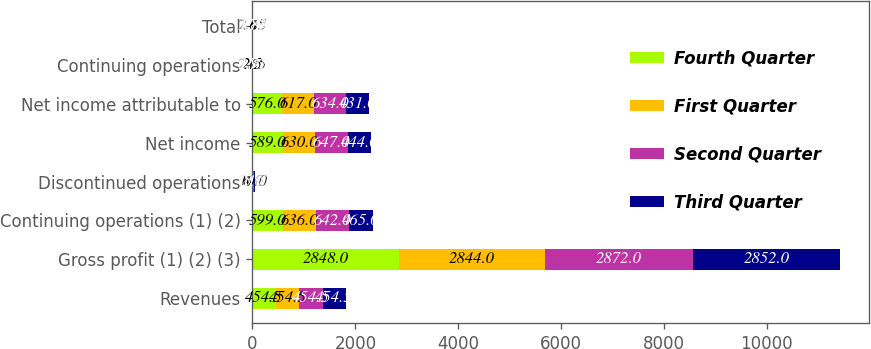Convert chart. <chart><loc_0><loc_0><loc_500><loc_500><stacked_bar_chart><ecel><fcel>Revenues<fcel>Gross profit (1) (2) (3)<fcel>Continuing operations (1) (2)<fcel>Discontinued operations<fcel>Net income<fcel>Net income attributable to<fcel>Continuing operations<fcel>Total<nl><fcel>Fourth Quarter<fcel>454.5<fcel>2848<fcel>599<fcel>10<fcel>589<fcel>576<fcel>2.5<fcel>2.45<nl><fcel>First Quarter<fcel>454.5<fcel>2844<fcel>636<fcel>6<fcel>630<fcel>617<fcel>2.65<fcel>2.63<nl><fcel>Second Quarter<fcel>454.5<fcel>2872<fcel>642<fcel>5<fcel>647<fcel>634<fcel>2.71<fcel>2.73<nl><fcel>Third Quarter<fcel>454.5<fcel>2852<fcel>465<fcel>21<fcel>444<fcel>431<fcel>1.97<fcel>1.88<nl></chart> 